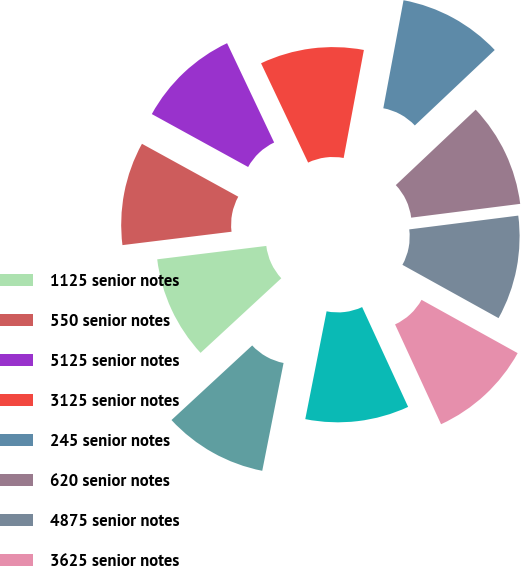Convert chart. <chart><loc_0><loc_0><loc_500><loc_500><pie_chart><fcel>1125 senior notes<fcel>550 senior notes<fcel>5125 senior notes<fcel>3125 senior notes<fcel>245 senior notes<fcel>620 senior notes<fcel>4875 senior notes<fcel>3625 senior notes<fcel>8375 debentures<fcel>550 notes<nl><fcel>9.93%<fcel>9.94%<fcel>9.96%<fcel>9.99%<fcel>10.01%<fcel>10.04%<fcel>10.06%<fcel>10.07%<fcel>9.98%<fcel>10.02%<nl></chart> 